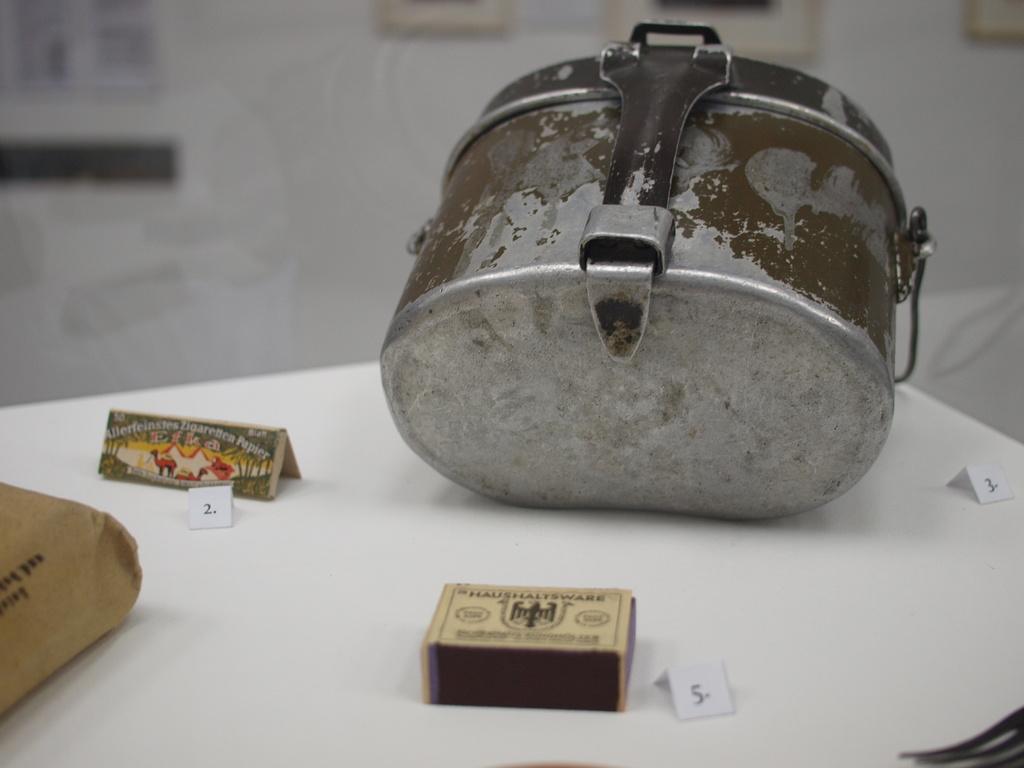In one or two sentences, can you explain what this image depicts? At the bottom of the image there is a table, on the table there are some papers and boxes. Behind the table there is wall, on the wall there are some frames. 